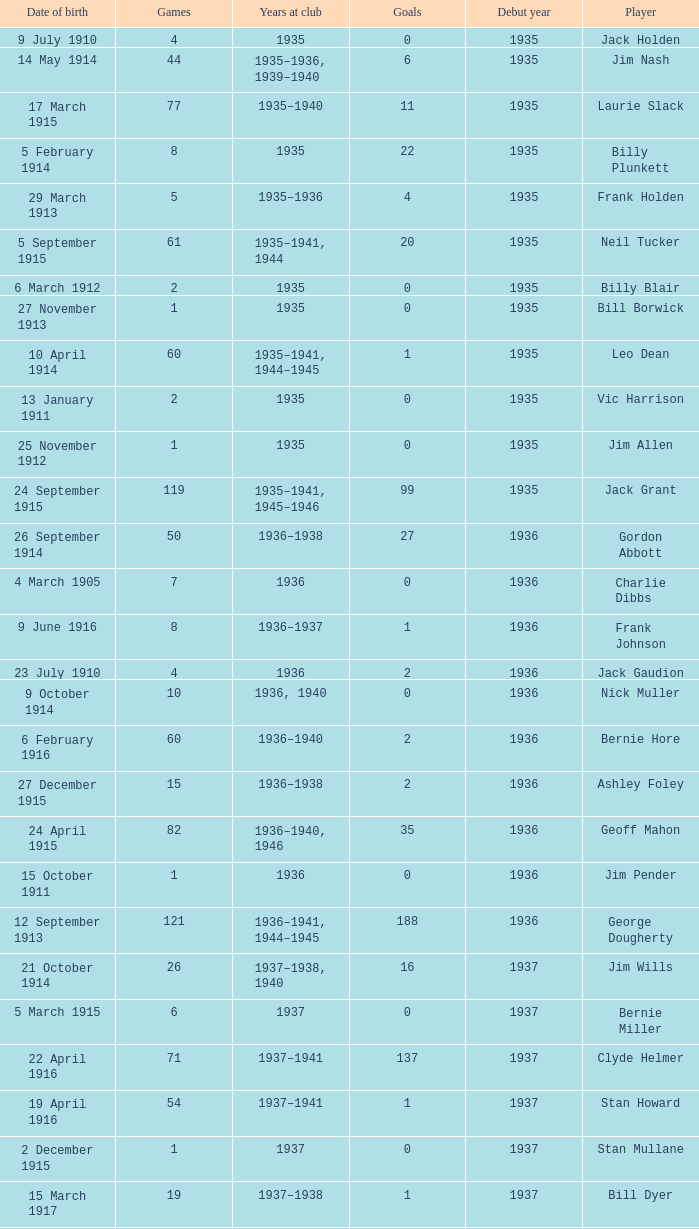How many games had 22 goals before 1935? None. 